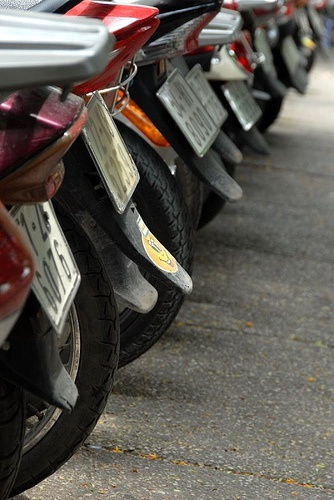Describe the objects in this image and their specific colors. I can see motorcycle in lightgray, black, gray, and maroon tones, motorcycle in lightgray, black, gray, maroon, and darkgray tones, motorcycle in lightgray, black, gray, and darkgray tones, motorcycle in lightgray, black, gray, maroon, and brown tones, and motorcycle in lightgray, black, gray, and darkgray tones in this image. 